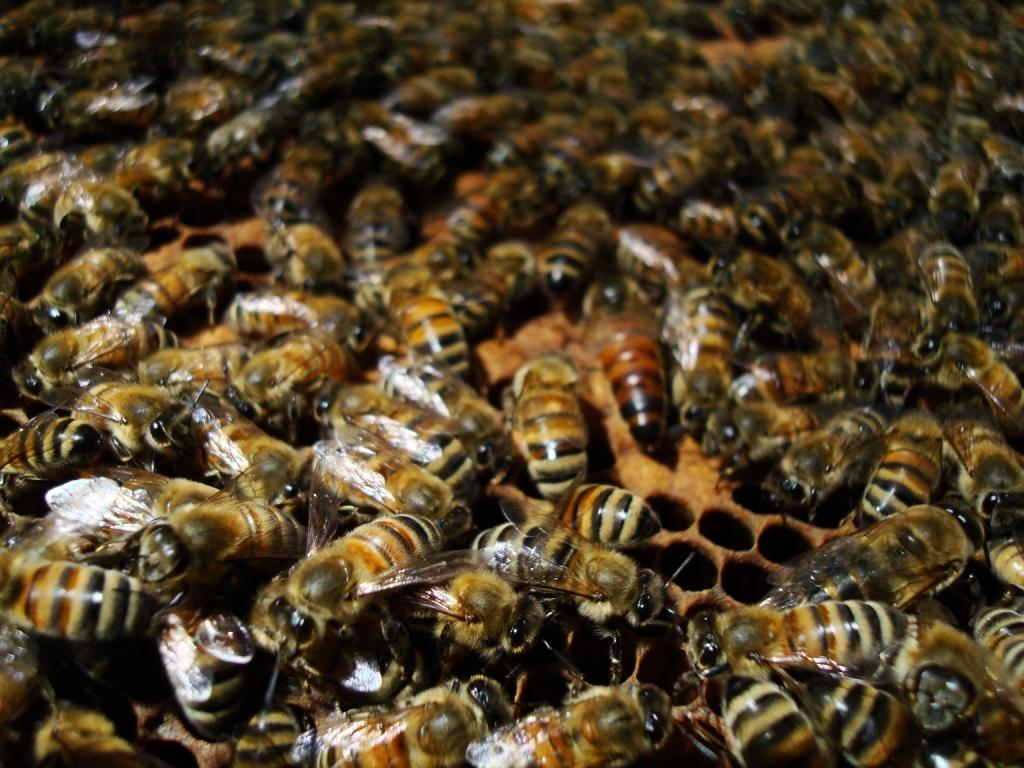What type of insects are present in the image? There are honey bees in the image. Can you describe the background of the image? The background of the image is blurred. What type of dinner is being served on the street in the image? There is no dinner or street present in the image; it features honey bees with a blurred background. 